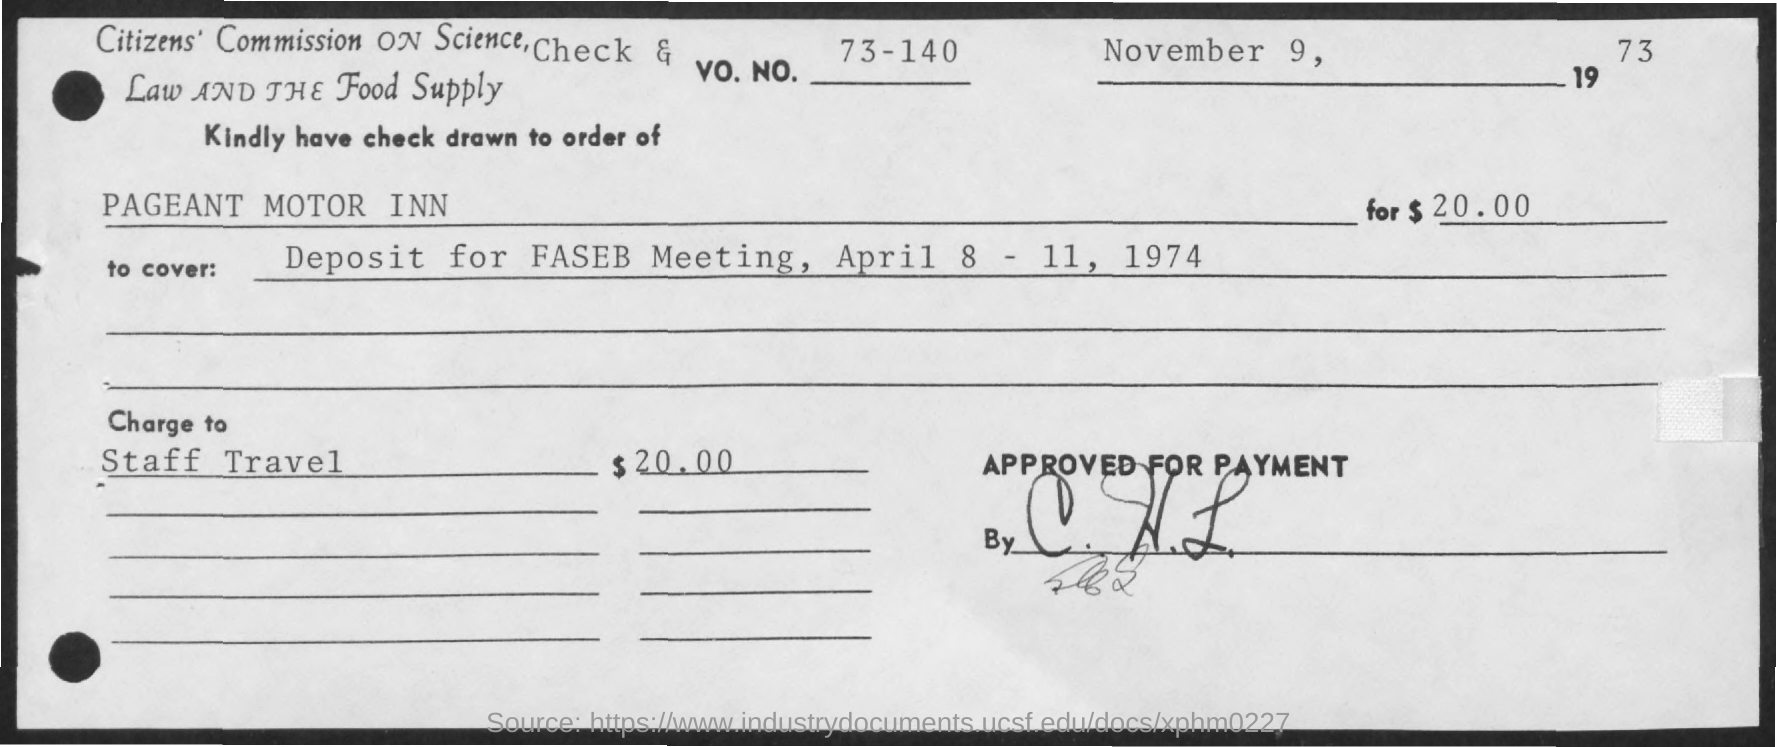Indicate a few pertinent items in this graphic. The date is November 9, 1973. The Vo. No. is 73-140. The amount mentioned is $20.00. 